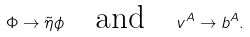<formula> <loc_0><loc_0><loc_500><loc_500>\Phi \rightarrow \tilde { \eta } \phi \quad \text {and} \quad v ^ { A } \rightarrow b ^ { A } .</formula> 